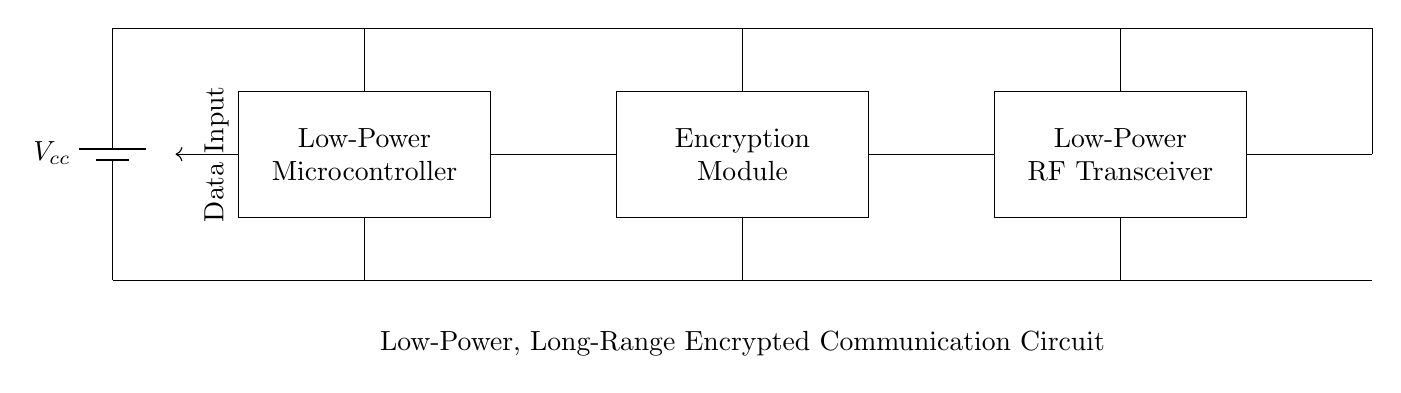What type of power supply is used? The circuit uses a battery, as indicated by the symbol labeled Vcc. This specifies that the power supply is a direct current source typically providing a stable voltage.
Answer: Battery What component encrypts the data? The circuit includes an encryption module, which is labeled explicitly. This module is responsible for securing data before transmission by enciphering it.
Answer: Encryption Module How many main components are there in the circuit? The circuit has four main components: a power supply, a microcontroller, an encryption module, and a low-power RF transceiver. Each of these components serves a specific function in the communication system.
Answer: Four What is the role of the low-power RF transceiver? The low-power RF transceiver facilitates wireless communication by transmitting and receiving data. This component is crucial for the circuit's long-range communication capability.
Answer: Wireless communication What connects the microcontroller to the encryption module? The microcontroller is connected to the encryption module through a direct line, indicating that data flows from the microcontroller to the encryption module for processing before transmission.
Answer: Direct connection How does the circuit ensure secure data transmission? The circuit uses an encryption module to secure data before it is sent through the low-power RF transceiver. The encryption transforms data into an unreadable format, which is then transmitted over the air.
Answer: Encryption What kind of antenna is used in the circuit? The antenna used in this circuit is a standard antenna symbol, which implies that it is designed for RF transmission, enabling the circuit to communicate over long distances in a secure manner.
Answer: RF antenna 